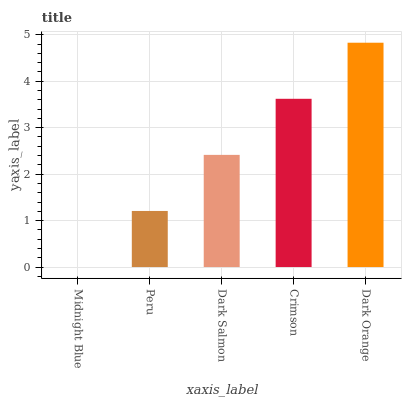Is Midnight Blue the minimum?
Answer yes or no. Yes. Is Dark Orange the maximum?
Answer yes or no. Yes. Is Peru the minimum?
Answer yes or no. No. Is Peru the maximum?
Answer yes or no. No. Is Peru greater than Midnight Blue?
Answer yes or no. Yes. Is Midnight Blue less than Peru?
Answer yes or no. Yes. Is Midnight Blue greater than Peru?
Answer yes or no. No. Is Peru less than Midnight Blue?
Answer yes or no. No. Is Dark Salmon the high median?
Answer yes or no. Yes. Is Dark Salmon the low median?
Answer yes or no. Yes. Is Midnight Blue the high median?
Answer yes or no. No. Is Dark Orange the low median?
Answer yes or no. No. 